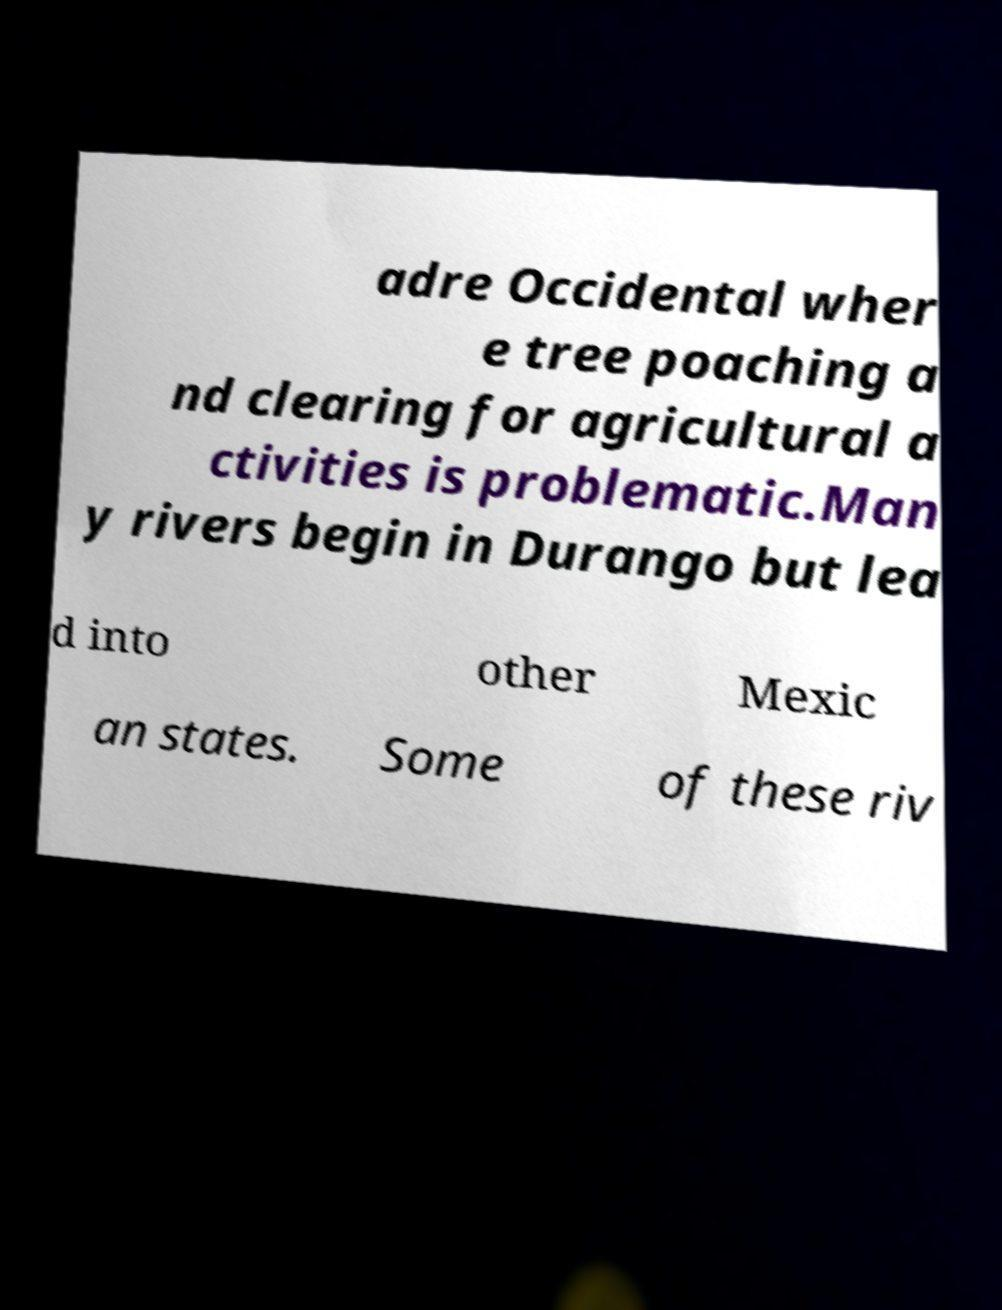What messages or text are displayed in this image? I need them in a readable, typed format. adre Occidental wher e tree poaching a nd clearing for agricultural a ctivities is problematic.Man y rivers begin in Durango but lea d into other Mexic an states. Some of these riv 